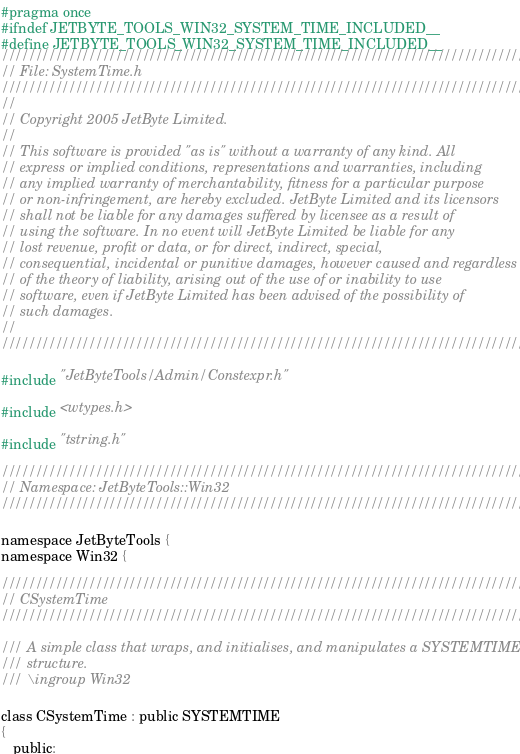<code> <loc_0><loc_0><loc_500><loc_500><_C_>#pragma once
#ifndef JETBYTE_TOOLS_WIN32_SYSTEM_TIME_INCLUDED__
#define JETBYTE_TOOLS_WIN32_SYSTEM_TIME_INCLUDED__
///////////////////////////////////////////////////////////////////////////////
// File: SystemTime.h
///////////////////////////////////////////////////////////////////////////////
//
// Copyright 2005 JetByte Limited.
//
// This software is provided "as is" without a warranty of any kind. All
// express or implied conditions, representations and warranties, including
// any implied warranty of merchantability, fitness for a particular purpose
// or non-infringement, are hereby excluded. JetByte Limited and its licensors
// shall not be liable for any damages suffered by licensee as a result of
// using the software. In no event will JetByte Limited be liable for any
// lost revenue, profit or data, or for direct, indirect, special,
// consequential, incidental or punitive damages, however caused and regardless
// of the theory of liability, arising out of the use of or inability to use
// software, even if JetByte Limited has been advised of the possibility of
// such damages.
//
///////////////////////////////////////////////////////////////////////////////

#include "JetByteTools/Admin/Constexpr.h"

#include <wtypes.h>

#include "tstring.h"

///////////////////////////////////////////////////////////////////////////////
// Namespace: JetByteTools::Win32
///////////////////////////////////////////////////////////////////////////////

namespace JetByteTools {
namespace Win32 {

///////////////////////////////////////////////////////////////////////////////
// CSystemTime
///////////////////////////////////////////////////////////////////////////////

/// A simple class that wraps, and initialises, and manipulates a SYSTEMTIME
/// structure.
/// \ingroup Win32

class CSystemTime : public SYSTEMTIME
{
   public:
</code> 